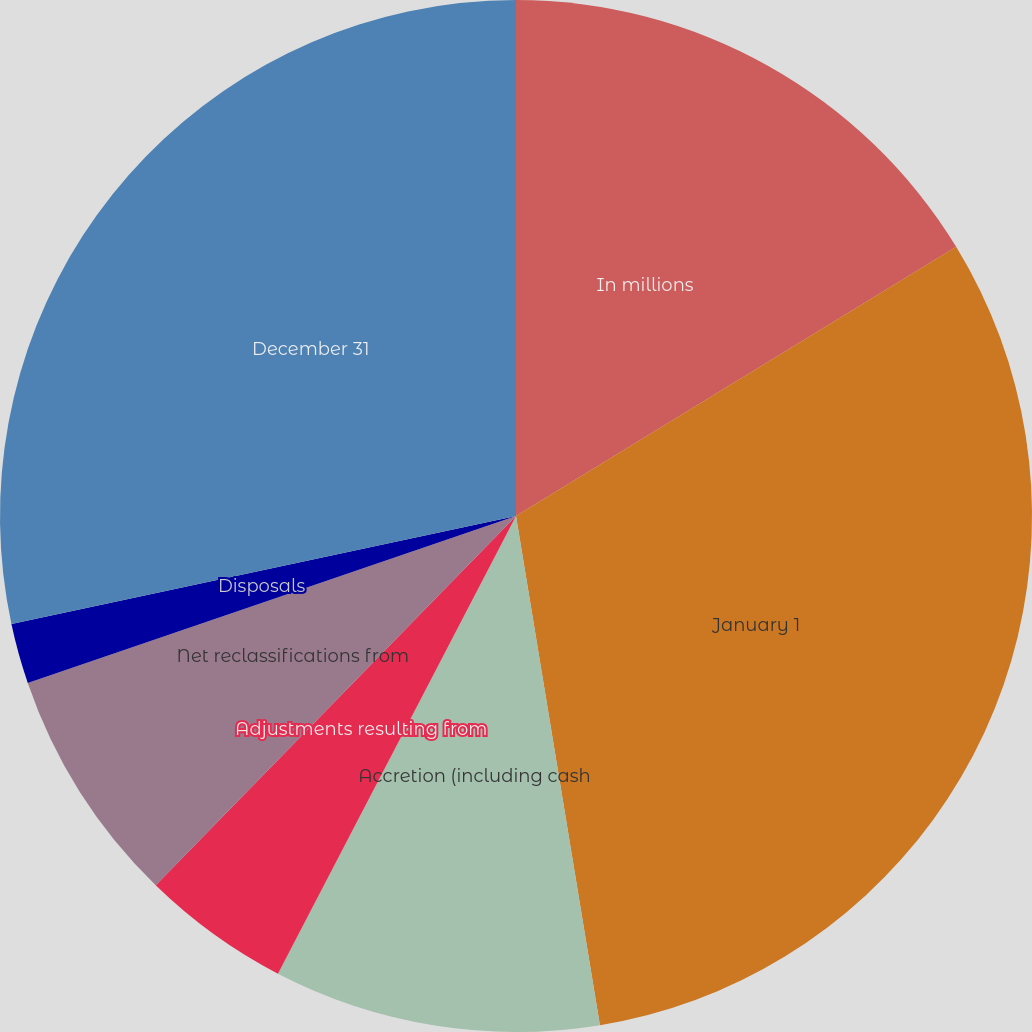Convert chart. <chart><loc_0><loc_0><loc_500><loc_500><pie_chart><fcel>In millions<fcel>January 1<fcel>Accretion (including cash<fcel>Adjustments resulting from<fcel>Net reclassifications from<fcel>Disposals<fcel>December 31<nl><fcel>16.26%<fcel>31.13%<fcel>10.23%<fcel>4.67%<fcel>7.45%<fcel>1.89%<fcel>28.35%<nl></chart> 